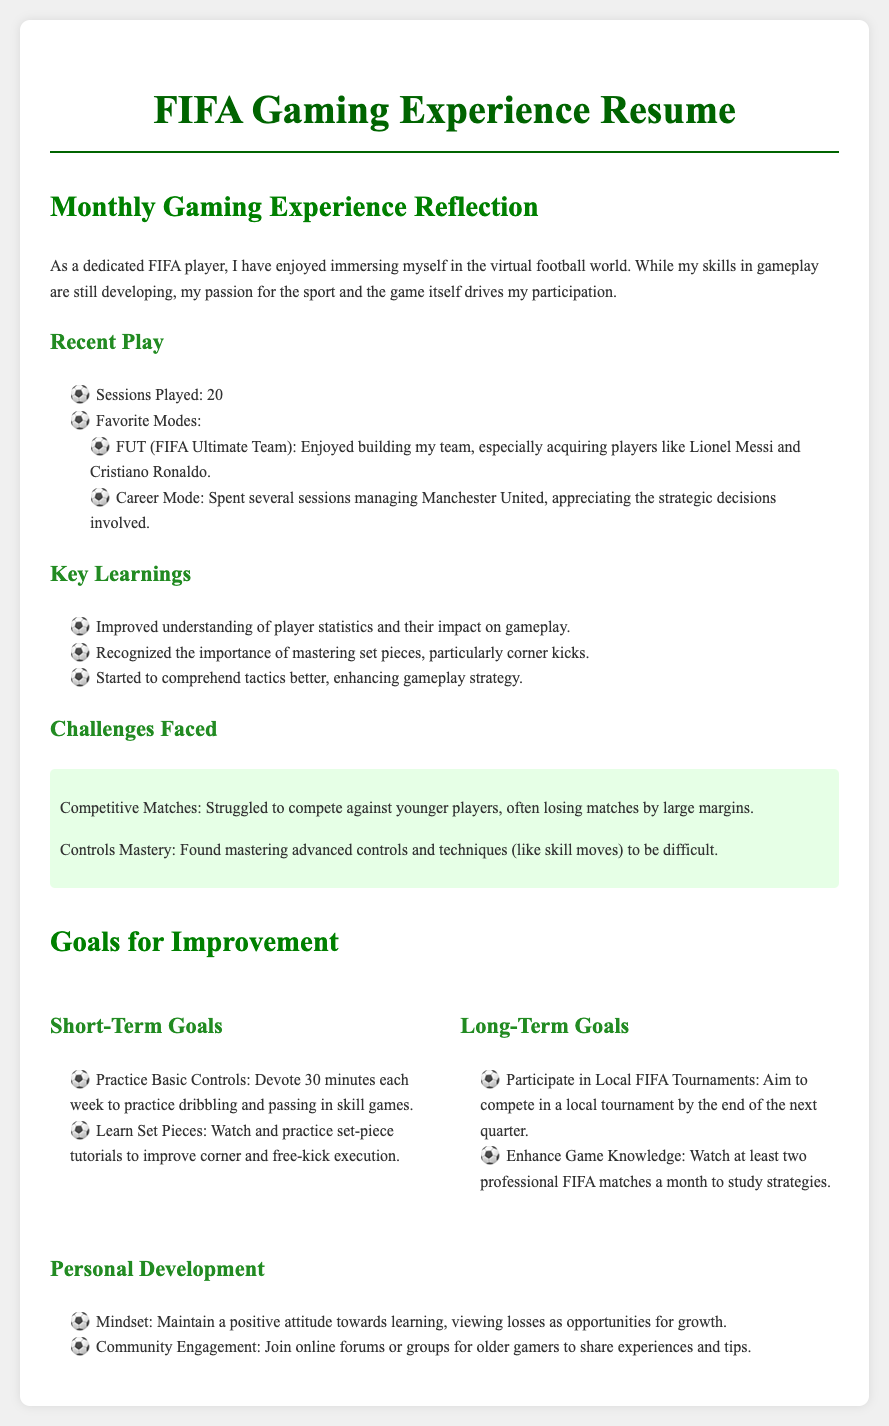What is the title of the document? The title of the document is given in the heading and indicates the subject matter of the resume focused on gaming.
Answer: FIFA Gaming Experience Resume How many sessions did the individual play? The specifics of the number of gaming sessions are listed in the document, providing a clear count of sessions played.
Answer: 20 What was one of the favorite modes listed? The document provides insights into the favorite gaming modes that the player enjoyed the most.
Answer: FUT What is one of the key learnings mentioned? The key learnings are outlined in a list, detailing significant insights gained during gaming sessions.
Answer: Importance of mastering set pieces What challenge did the individual face? The challenges faced by the player are highlighted and provide an understanding of their difficulties within the game.
Answer: Competitive matches What is one of the short-term goals for improvement? The document lists specific short-term goals the player aims to achieve to enhance their gameplay.
Answer: Practice Basic Controls What type of mindset does the individual aim to maintain? The personal development section reflects on the mindset the player wants to adopt towards learning and improvement.
Answer: Positive attitude How many professional FIFA matches does the individual plan to watch monthly? The long-term goals include a plan related to watching professional matches for improvement in strategy understanding.
Answer: Two When does the player aim to participate in a local tournament? The document specifies the time frame within which the player plans to compete in a local tournament.
Answer: End of the next quarter 